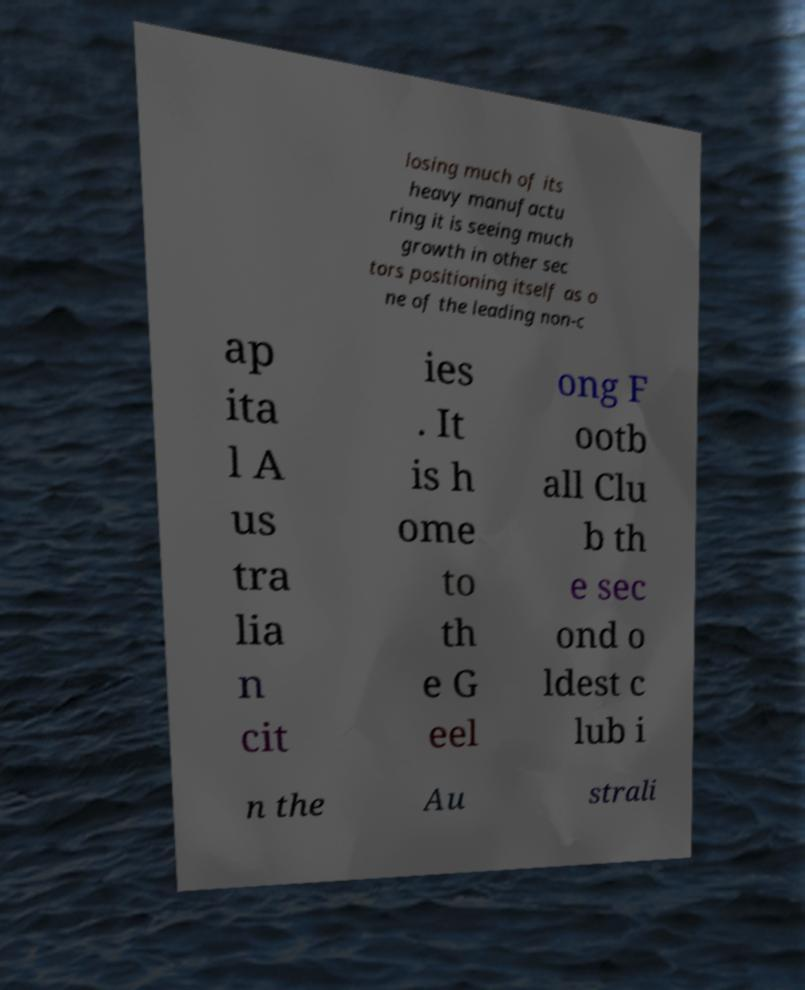I need the written content from this picture converted into text. Can you do that? losing much of its heavy manufactu ring it is seeing much growth in other sec tors positioning itself as o ne of the leading non-c ap ita l A us tra lia n cit ies . It is h ome to th e G eel ong F ootb all Clu b th e sec ond o ldest c lub i n the Au strali 